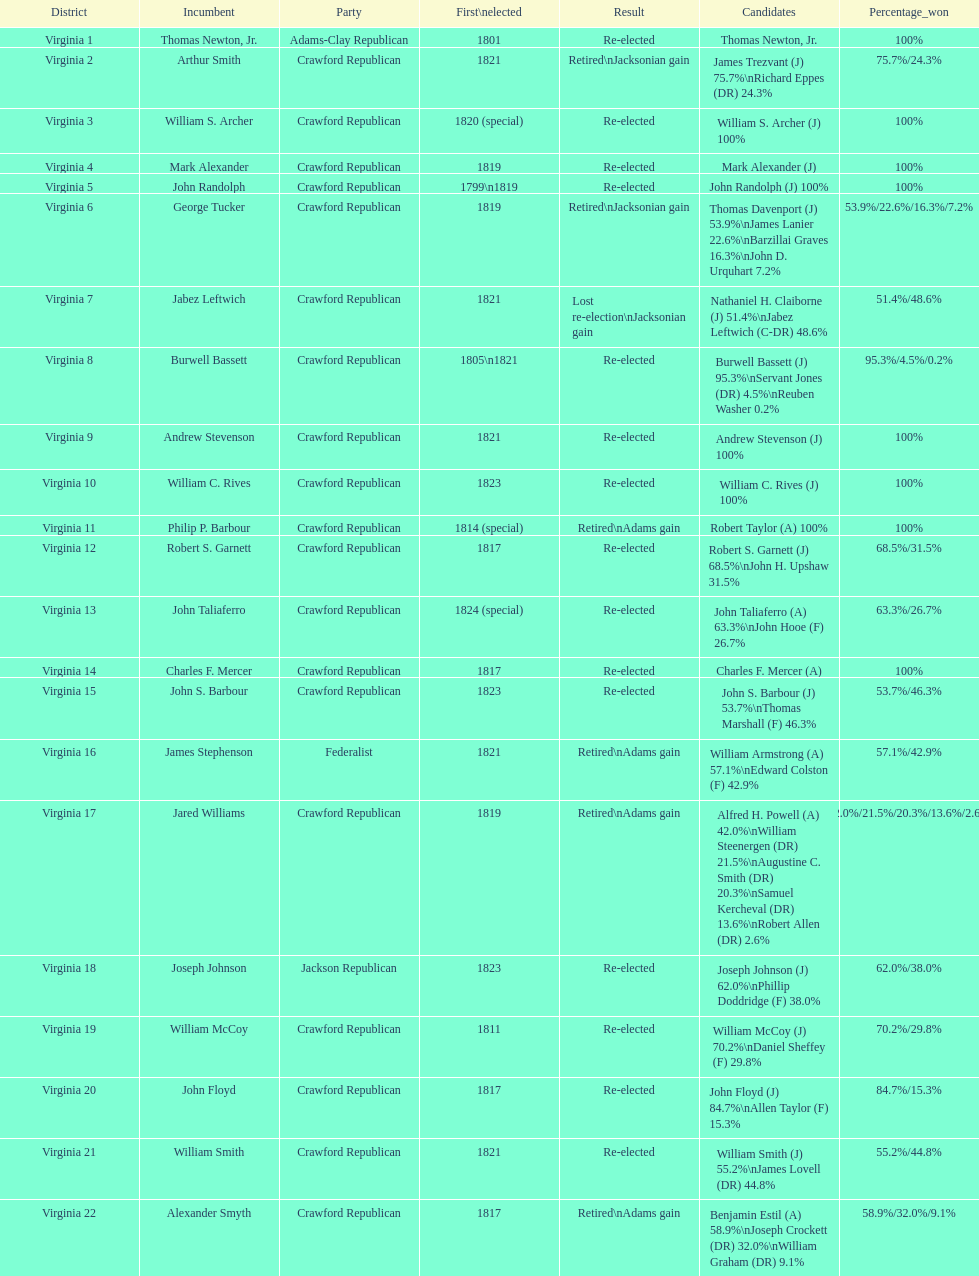Who was the next incumbent after john randolph? George Tucker. 